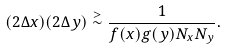<formula> <loc_0><loc_0><loc_500><loc_500>( 2 \Delta x ) ( 2 \Delta y ) \stackrel { > } { \sim } \frac { 1 } { f ( x ) g ( y ) N _ { x } N _ { y } } .</formula> 